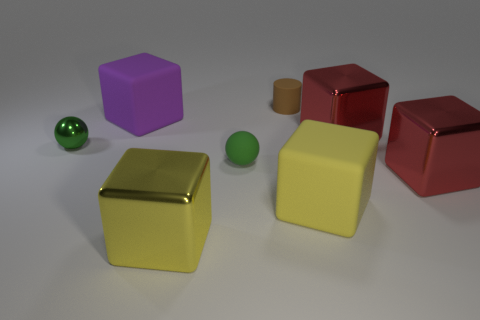Are there any other things that are the same shape as the large yellow matte thing?
Ensure brevity in your answer.  Yes. What number of balls are big purple objects or rubber things?
Provide a succinct answer. 1. What shape is the green shiny thing?
Offer a terse response. Sphere. There is a yellow metal cube; are there any large yellow matte objects in front of it?
Make the answer very short. No. Is the material of the small brown thing the same as the small green object that is behind the tiny matte ball?
Make the answer very short. No. There is a small object that is to the right of the small rubber ball; is its shape the same as the green rubber thing?
Provide a succinct answer. No. How many tiny green objects are the same material as the brown thing?
Your answer should be compact. 1. What number of things are either large things behind the large yellow metallic thing or large purple objects?
Provide a short and direct response. 4. What is the size of the yellow metal thing?
Keep it short and to the point. Large. What is the red block that is on the right side of the large metallic object behind the small matte ball made of?
Your response must be concise. Metal. 